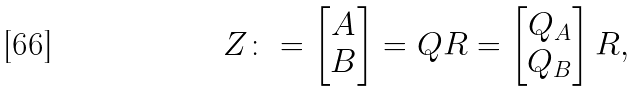Convert formula to latex. <formula><loc_0><loc_0><loc_500><loc_500>Z \colon = \begin{bmatrix} A \\ B \end{bmatrix} = Q R = \begin{bmatrix} Q _ { A } \\ Q _ { B } \end{bmatrix} R ,</formula> 